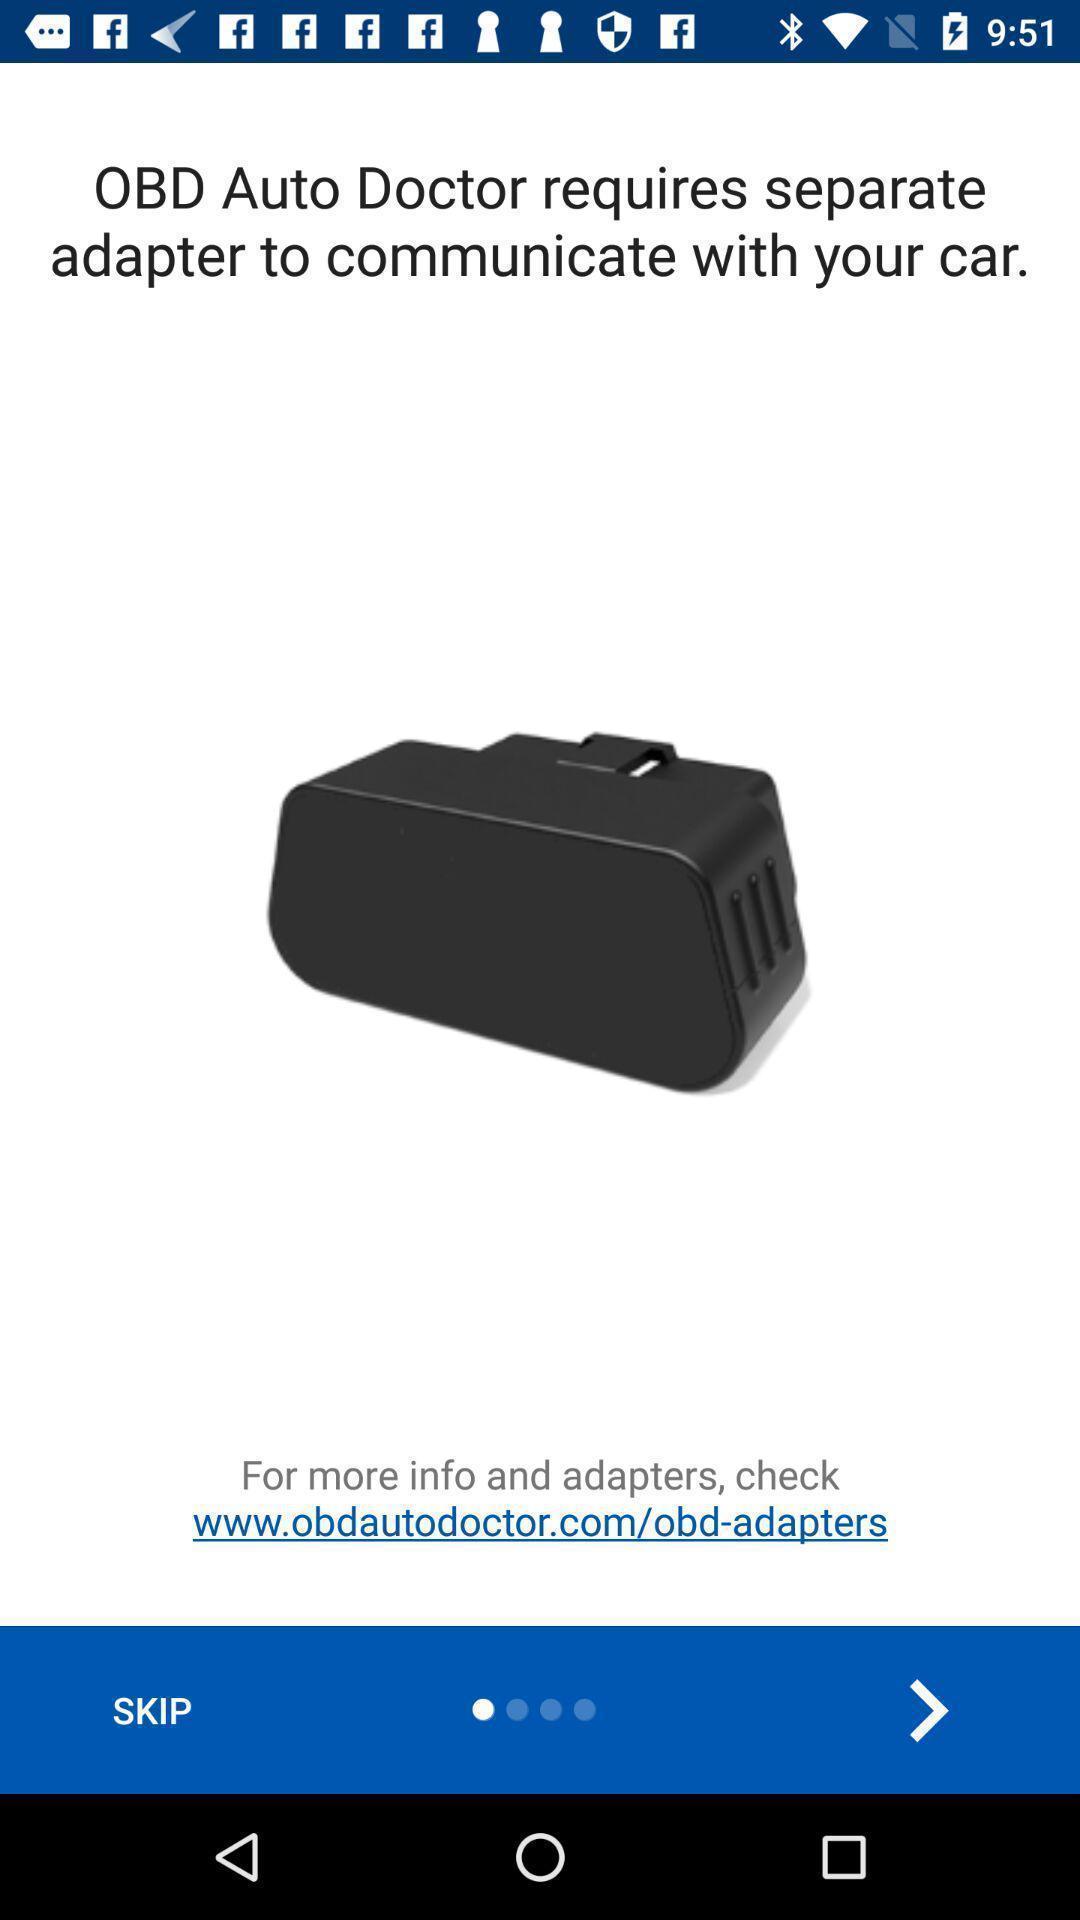Provide a detailed account of this screenshot. Screen displaying information about the application. 